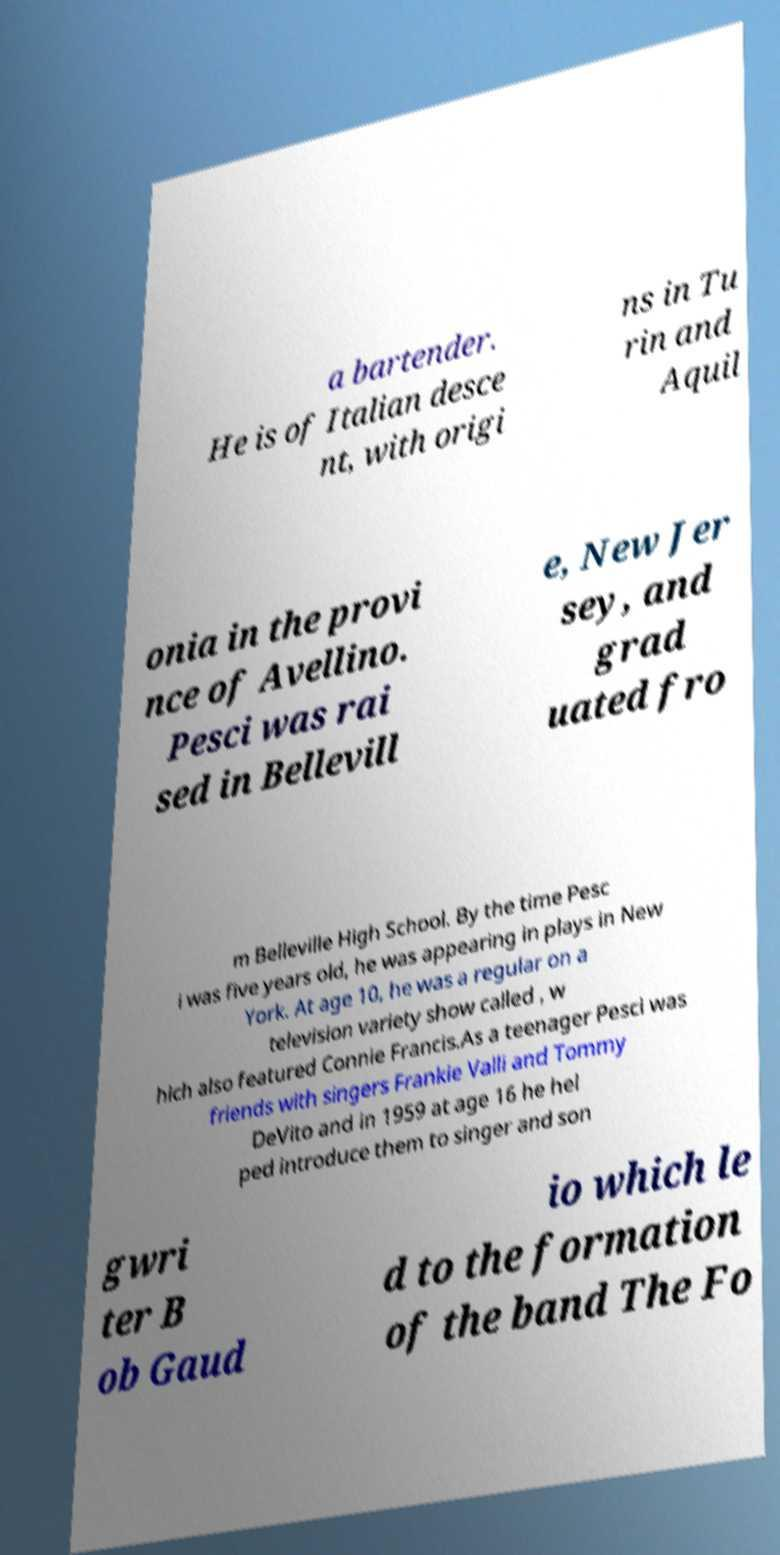I need the written content from this picture converted into text. Can you do that? a bartender. He is of Italian desce nt, with origi ns in Tu rin and Aquil onia in the provi nce of Avellino. Pesci was rai sed in Bellevill e, New Jer sey, and grad uated fro m Belleville High School. By the time Pesc i was five years old, he was appearing in plays in New York. At age 10, he was a regular on a television variety show called , w hich also featured Connie Francis.As a teenager Pesci was friends with singers Frankie Valli and Tommy DeVito and in 1959 at age 16 he hel ped introduce them to singer and son gwri ter B ob Gaud io which le d to the formation of the band The Fo 